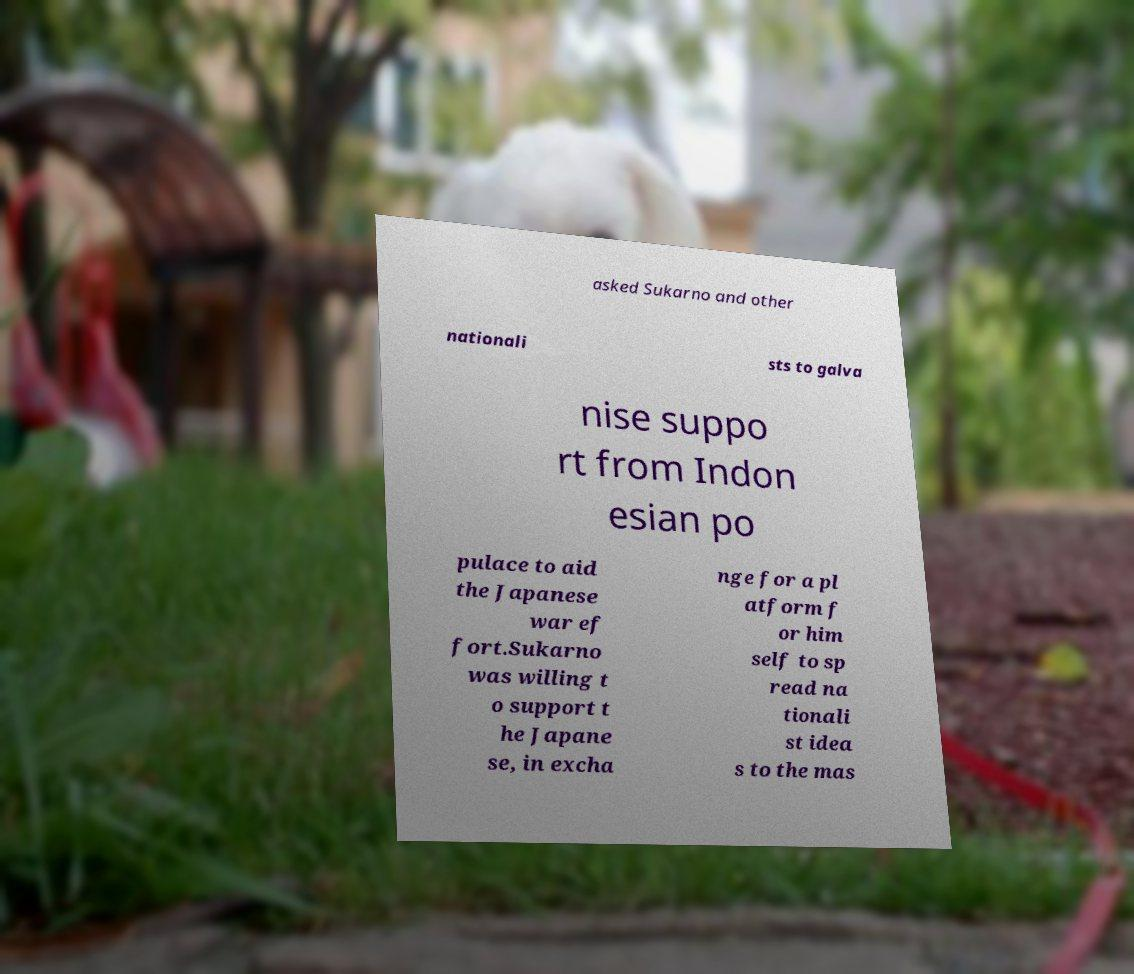What messages or text are displayed in this image? I need them in a readable, typed format. asked Sukarno and other nationali sts to galva nise suppo rt from Indon esian po pulace to aid the Japanese war ef fort.Sukarno was willing t o support t he Japane se, in excha nge for a pl atform f or him self to sp read na tionali st idea s to the mas 